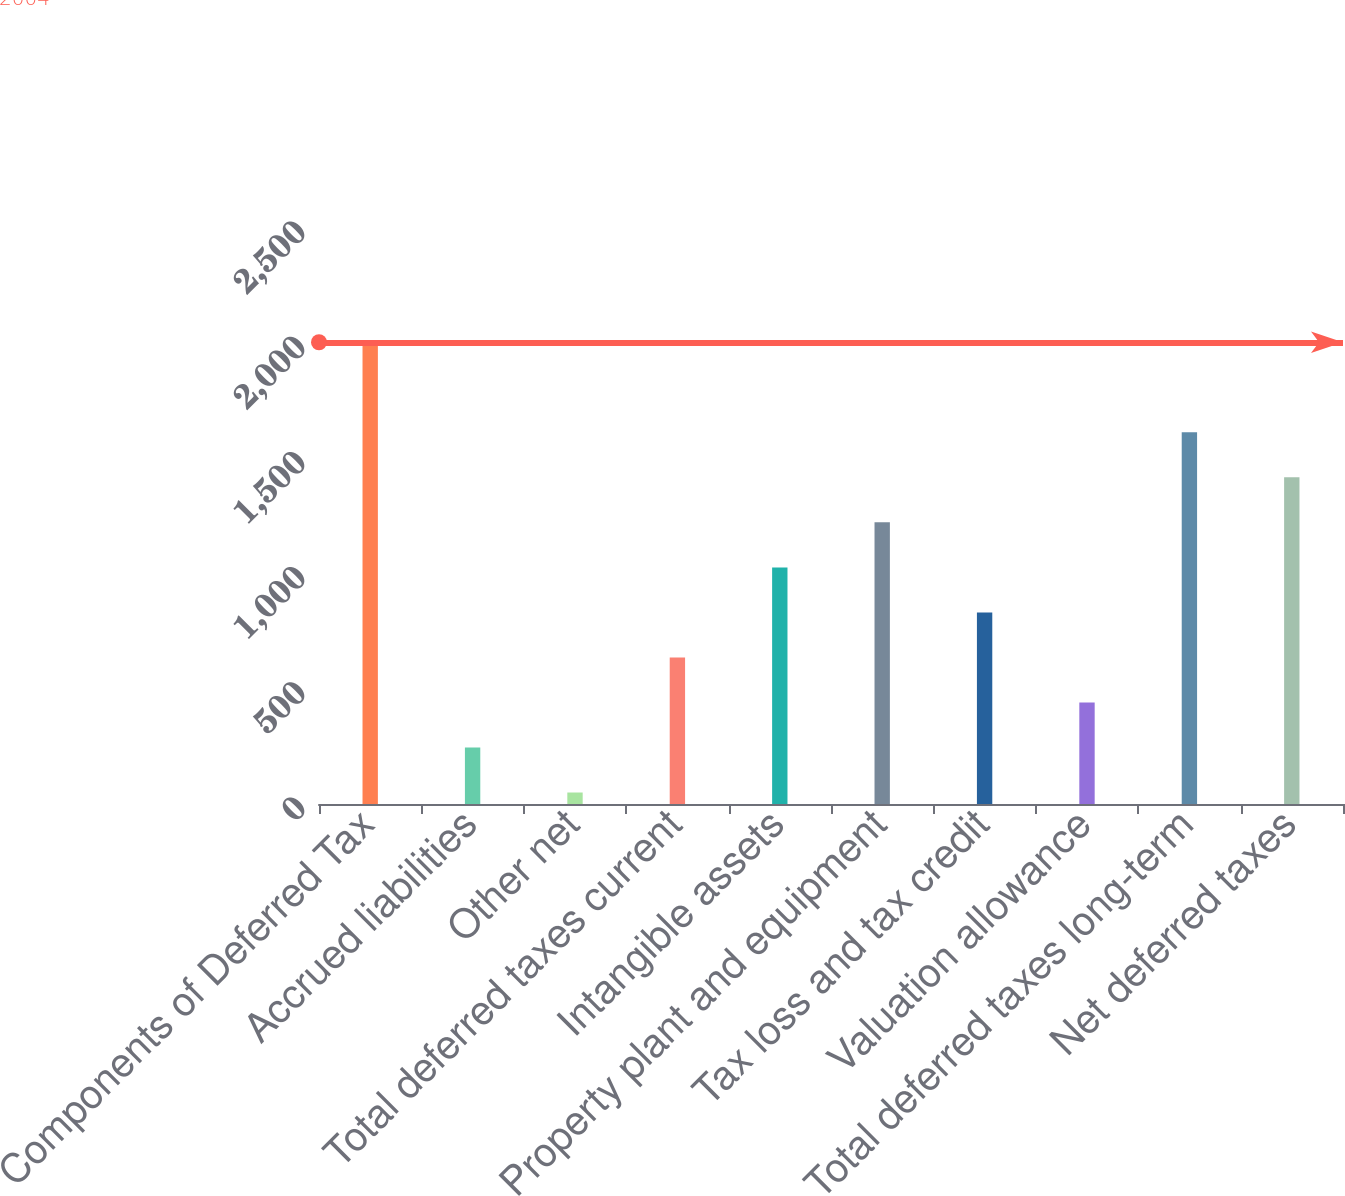Convert chart to OTSL. <chart><loc_0><loc_0><loc_500><loc_500><bar_chart><fcel>Components of Deferred Tax<fcel>Accrued liabilities<fcel>Other net<fcel>Total deferred taxes current<fcel>Intangible assets<fcel>Property plant and equipment<fcel>Tax loss and tax credit<fcel>Valuation allowance<fcel>Total deferred taxes long-term<fcel>Net deferred taxes<nl><fcel>2004<fcel>245.31<fcel>49.9<fcel>636.13<fcel>1026.95<fcel>1222.36<fcel>831.54<fcel>440.72<fcel>1613.18<fcel>1417.77<nl></chart> 